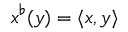<formula> <loc_0><loc_0><loc_500><loc_500>x ^ { \flat } ( y ) = \langle x , y \rangle</formula> 